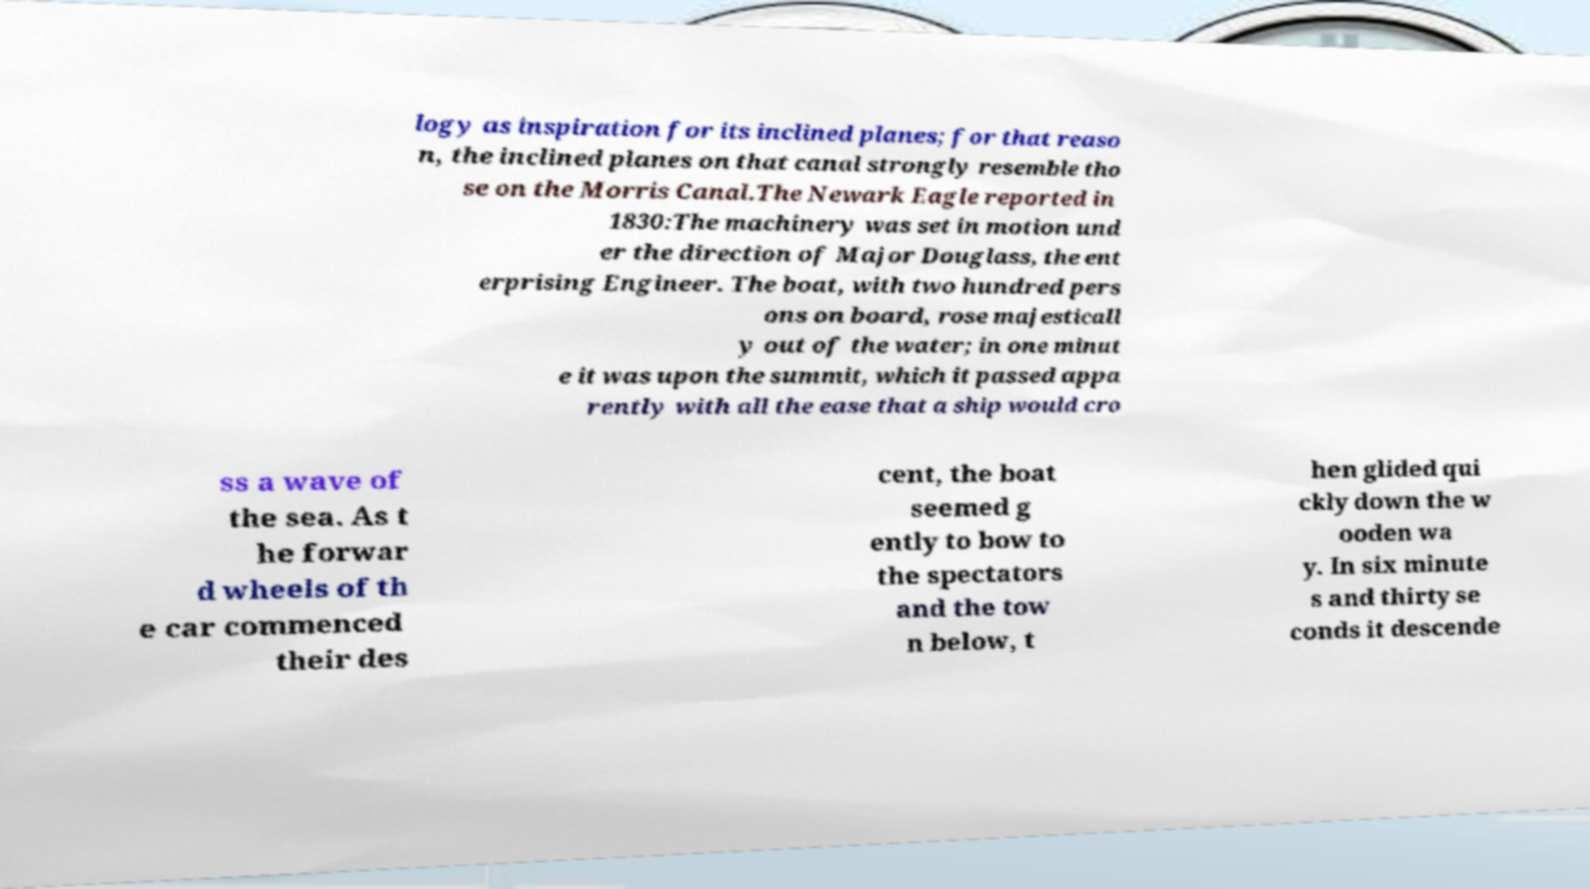I need the written content from this picture converted into text. Can you do that? logy as inspiration for its inclined planes; for that reaso n, the inclined planes on that canal strongly resemble tho se on the Morris Canal.The Newark Eagle reported in 1830:The machinery was set in motion und er the direction of Major Douglass, the ent erprising Engineer. The boat, with two hundred pers ons on board, rose majesticall y out of the water; in one minut e it was upon the summit, which it passed appa rently with all the ease that a ship would cro ss a wave of the sea. As t he forwar d wheels of th e car commenced their des cent, the boat seemed g ently to bow to the spectators and the tow n below, t hen glided qui ckly down the w ooden wa y. In six minute s and thirty se conds it descende 